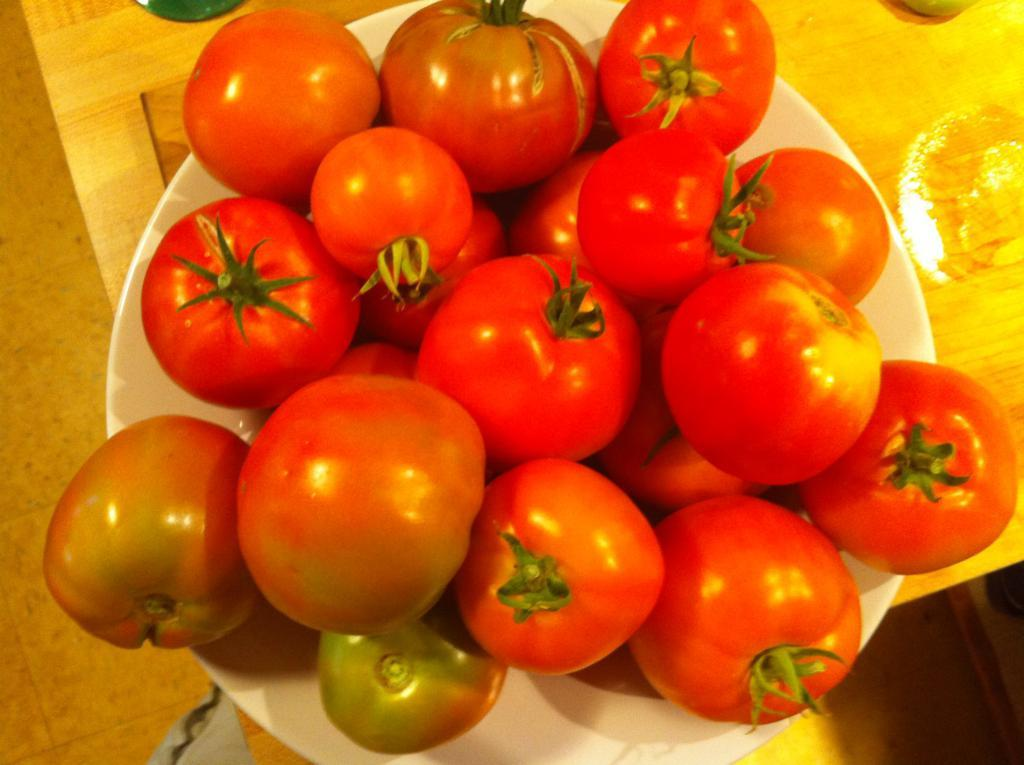What is in the bowl that is visible in the image? The bowl contains tomatoes. Can you describe the contents of the bowl in more detail? The bowl contains tomatoes, which are a type of fruit commonly used in cooking and salads. Is there a knot tied in the tomatoes in the image? No, there is no knot tied in the tomatoes in the image. The tomatoes are simply placed in the bowl. 